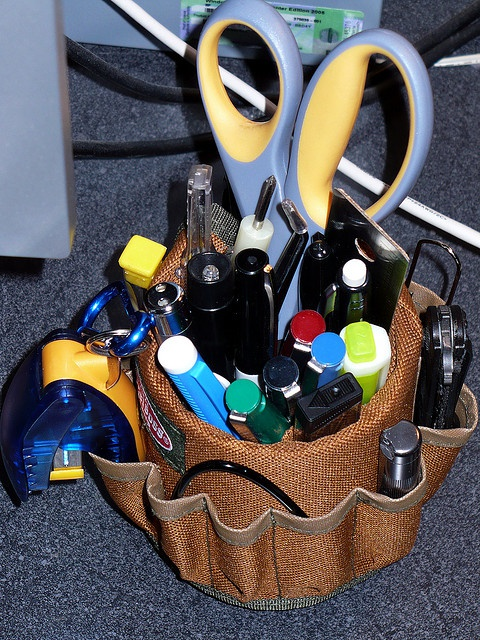Describe the objects in this image and their specific colors. I can see scissors in darkgray, black, and khaki tones in this image. 